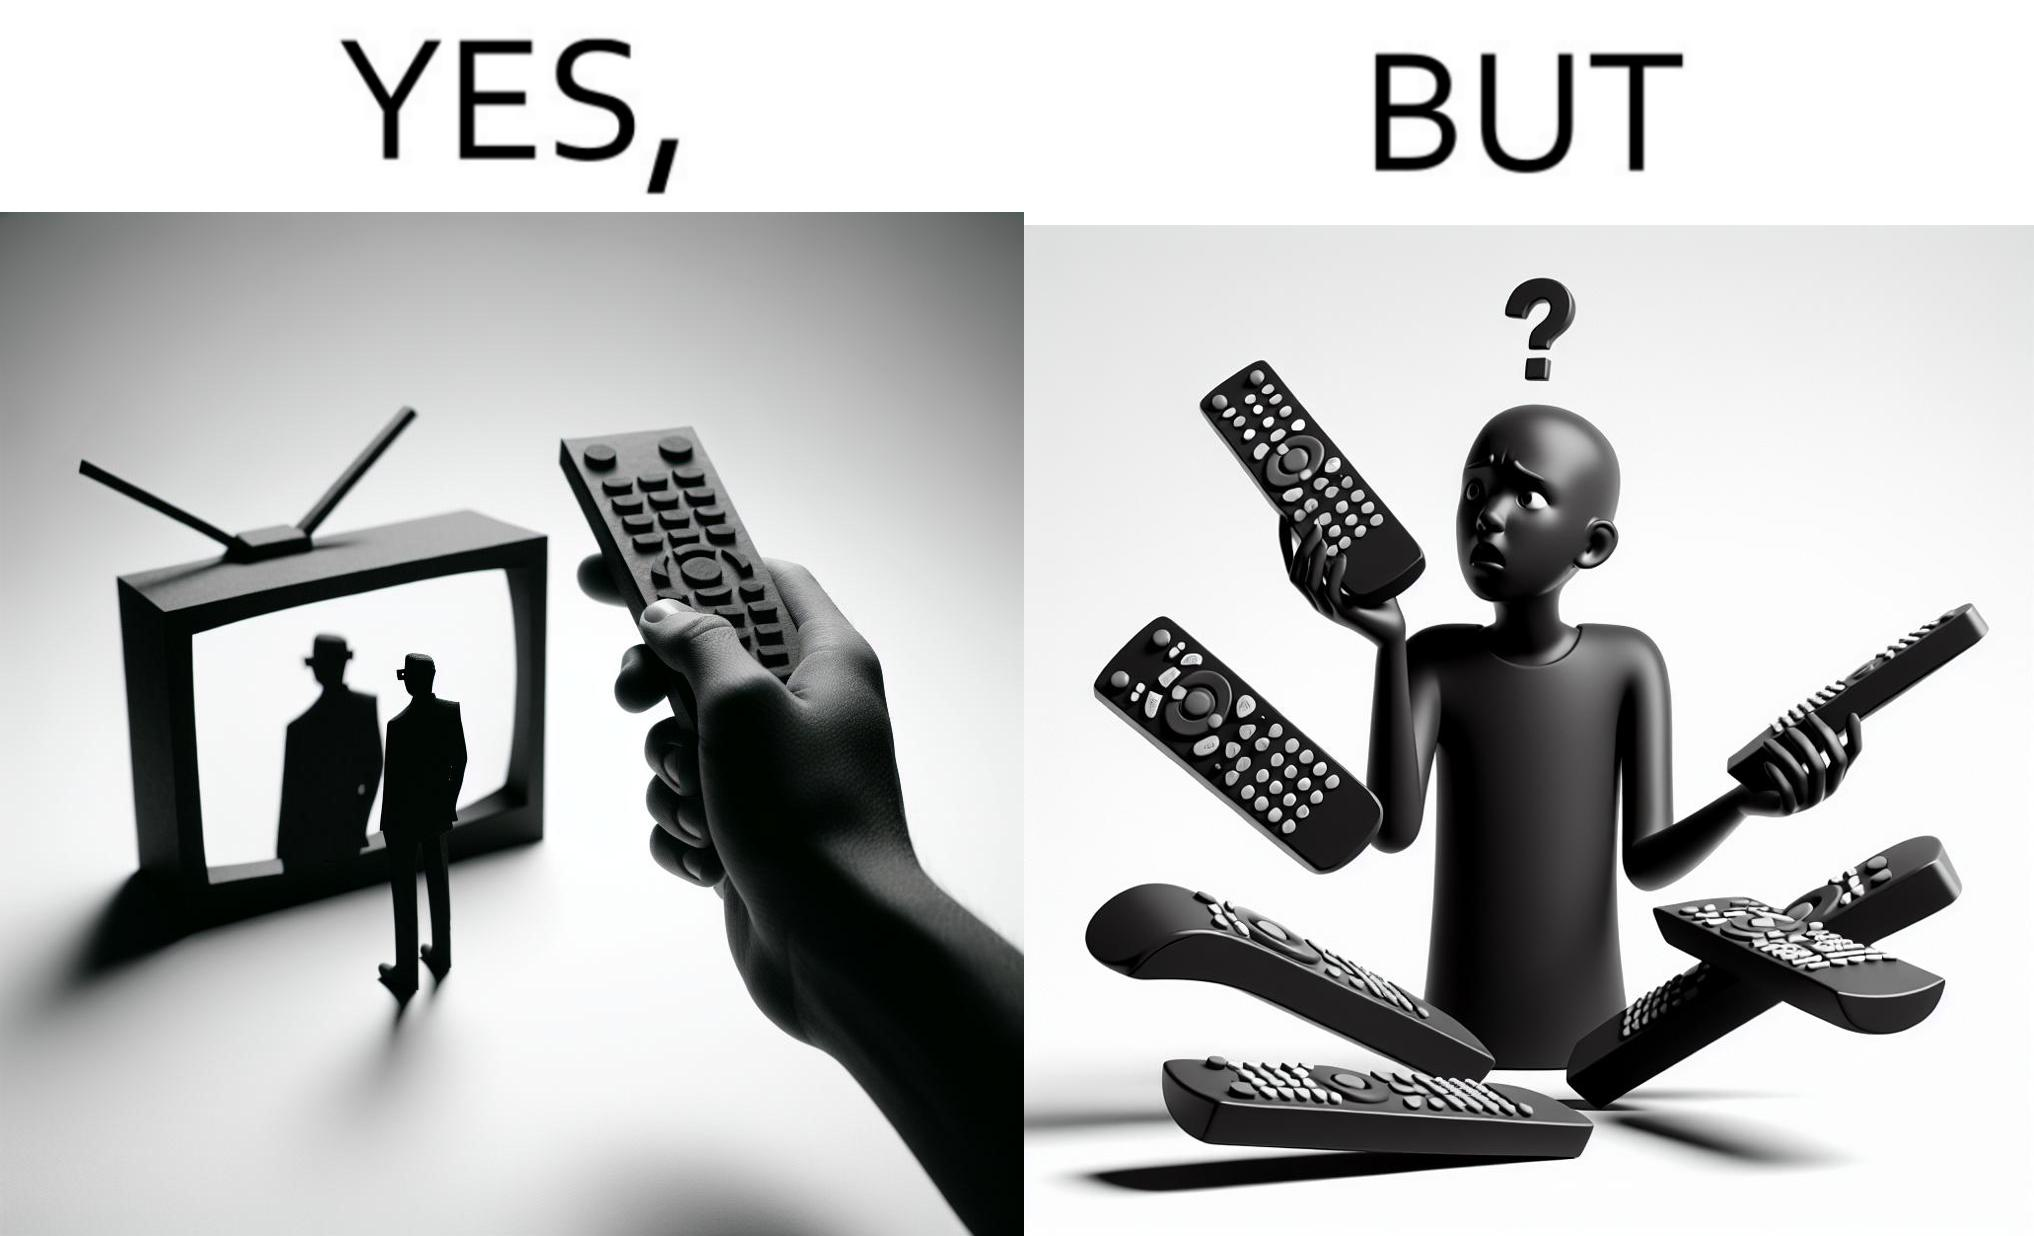Describe what you see in this image. The images are funny since they show how even though TV remotes are supposed to make operating TVs easier, having multiple similar looking remotes  for everything only makes it more difficult for the user to use the right one 